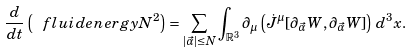<formula> <loc_0><loc_0><loc_500><loc_500>\frac { d } { d t } \left ( \ f l u i d e n e r g y { N } ^ { 2 } \right ) & = \sum _ { | \vec { \alpha } | \leq N } \int _ { \mathbb { R } ^ { 3 } } \partial _ { \mu } \left ( \dot { J } ^ { \mu } [ \partial _ { \vec { \alpha } } W , \partial _ { \vec { \alpha } } W ] \right ) \, d ^ { 3 } x .</formula> 